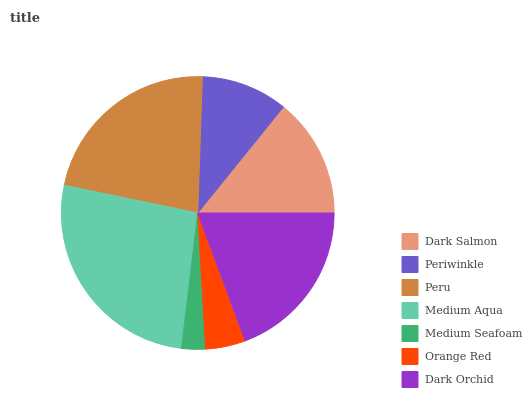Is Medium Seafoam the minimum?
Answer yes or no. Yes. Is Medium Aqua the maximum?
Answer yes or no. Yes. Is Periwinkle the minimum?
Answer yes or no. No. Is Periwinkle the maximum?
Answer yes or no. No. Is Dark Salmon greater than Periwinkle?
Answer yes or no. Yes. Is Periwinkle less than Dark Salmon?
Answer yes or no. Yes. Is Periwinkle greater than Dark Salmon?
Answer yes or no. No. Is Dark Salmon less than Periwinkle?
Answer yes or no. No. Is Dark Salmon the high median?
Answer yes or no. Yes. Is Dark Salmon the low median?
Answer yes or no. Yes. Is Medium Seafoam the high median?
Answer yes or no. No. Is Periwinkle the low median?
Answer yes or no. No. 